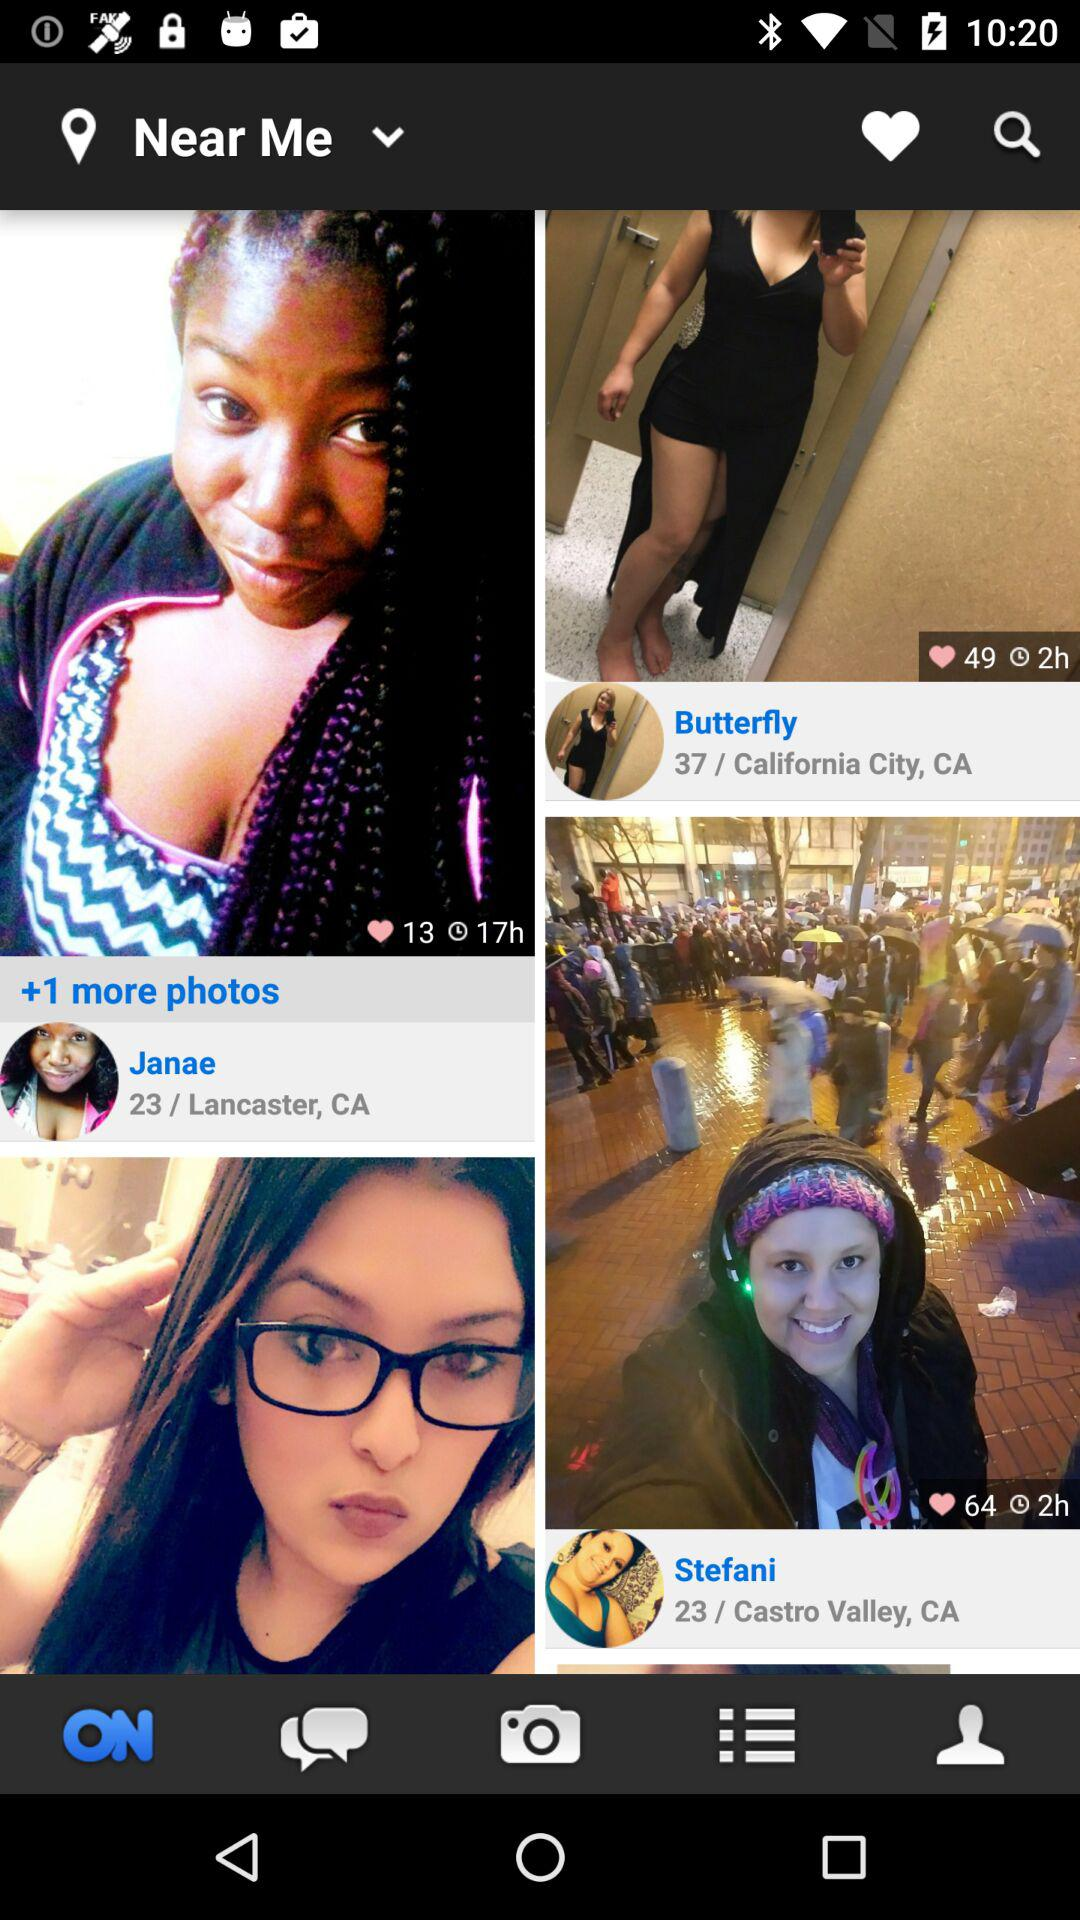What is the name of the user that has got 49 likes? The name of the user who has got 49 likes is "Butterfly". 